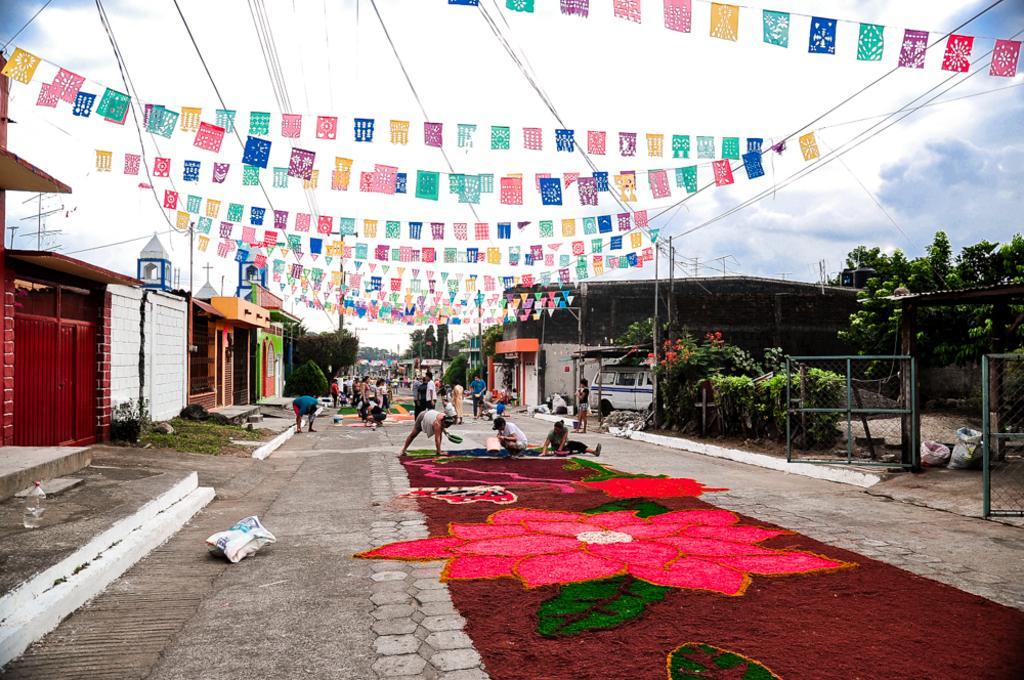How would you summarize this image in a sentence or two? In the center of the picture it is a street, on the street there are people and rangoli arts. On the right there are trees, fencing, car and buildings. On the left there are trees and buildings. At the top there cables, ribbons and sky. In the center of the background we can see trees. 